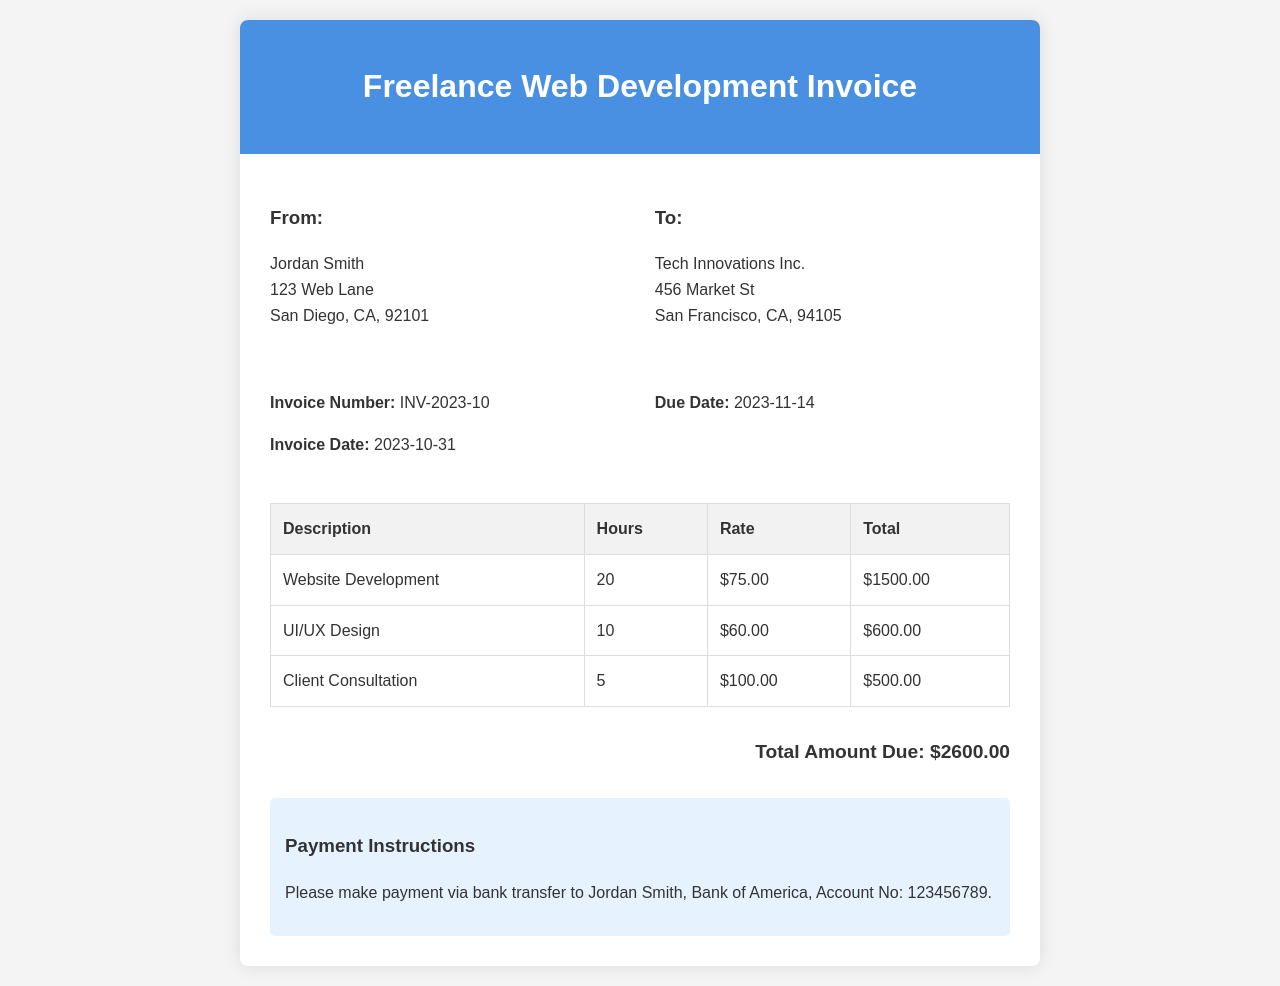what is the invoice number? The invoice number is specified prominently in the document as a unique identifier for this invoice.
Answer: INV-2023-10 what is the due date? The due date indicates when the payment for the invoice must be made.
Answer: 2023-11-14 who is the recipient of this invoice? This information identifies the entity to which the invoice is sent.
Answer: Tech Innovations Inc how many hours were billed for Website Development? The number of hours worked on Website Development is detailed in the itemized breakdown.
Answer: 20 what is the total amount due? The total amount is the sum of all charges listed in the invoice.
Answer: $2600.00 what is the payment method specified? This section contains instructions regarding how to make the payment for the invoice.
Answer: bank transfer how many hours were billed for Client Consultation? This information provides insight into the time spent specifically on client consultation activities.
Answer: 5 what is the hourly rate for UI/UX Design? The hourly rate provides specific pricing information for the services rendered.
Answer: $60.00 who is the sender of the invoice? The sender's details are provided to clarify who is requesting the payment.
Answer: Jordan Smith 